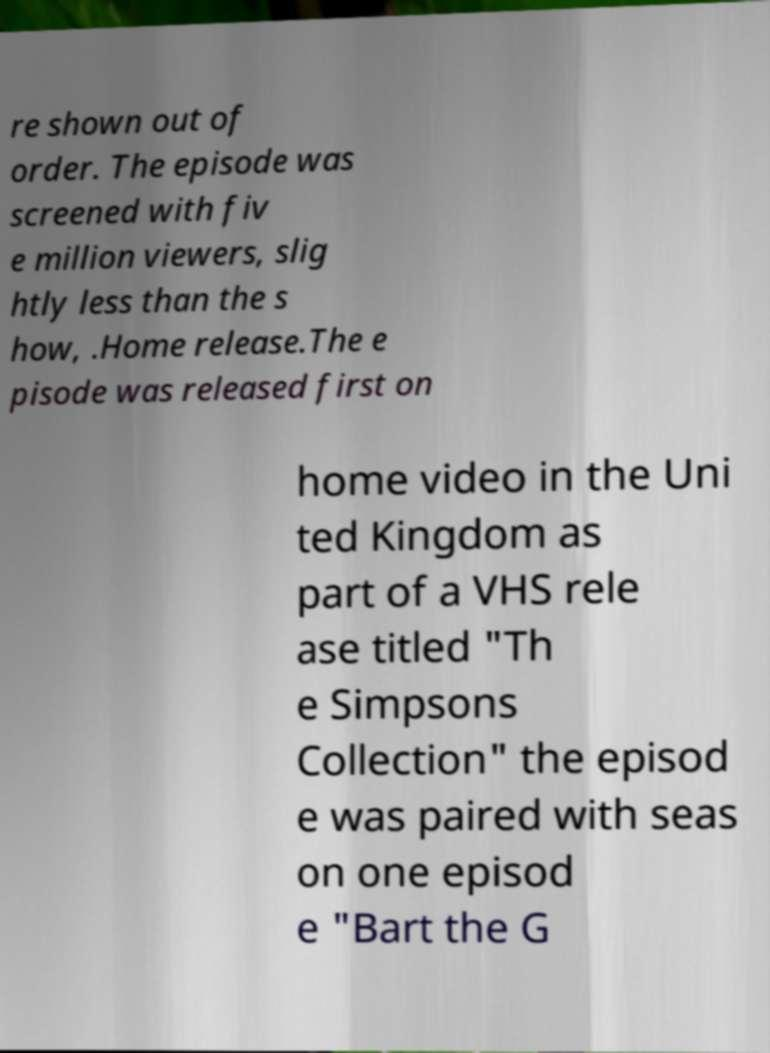Can you accurately transcribe the text from the provided image for me? re shown out of order. The episode was screened with fiv e million viewers, slig htly less than the s how, .Home release.The e pisode was released first on home video in the Uni ted Kingdom as part of a VHS rele ase titled "Th e Simpsons Collection" the episod e was paired with seas on one episod e "Bart the G 